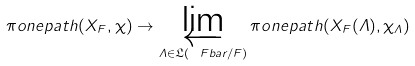Convert formula to latex. <formula><loc_0><loc_0><loc_500><loc_500>\pi o n e p a t h ( X _ { F } , \chi ) \to \varprojlim _ { \varLambda \in \mathfrak { L } ( \ F b a r / F ) } \pi o n e p a t h ( X _ { F } ( \varLambda ) , \chi _ { \varLambda } )</formula> 